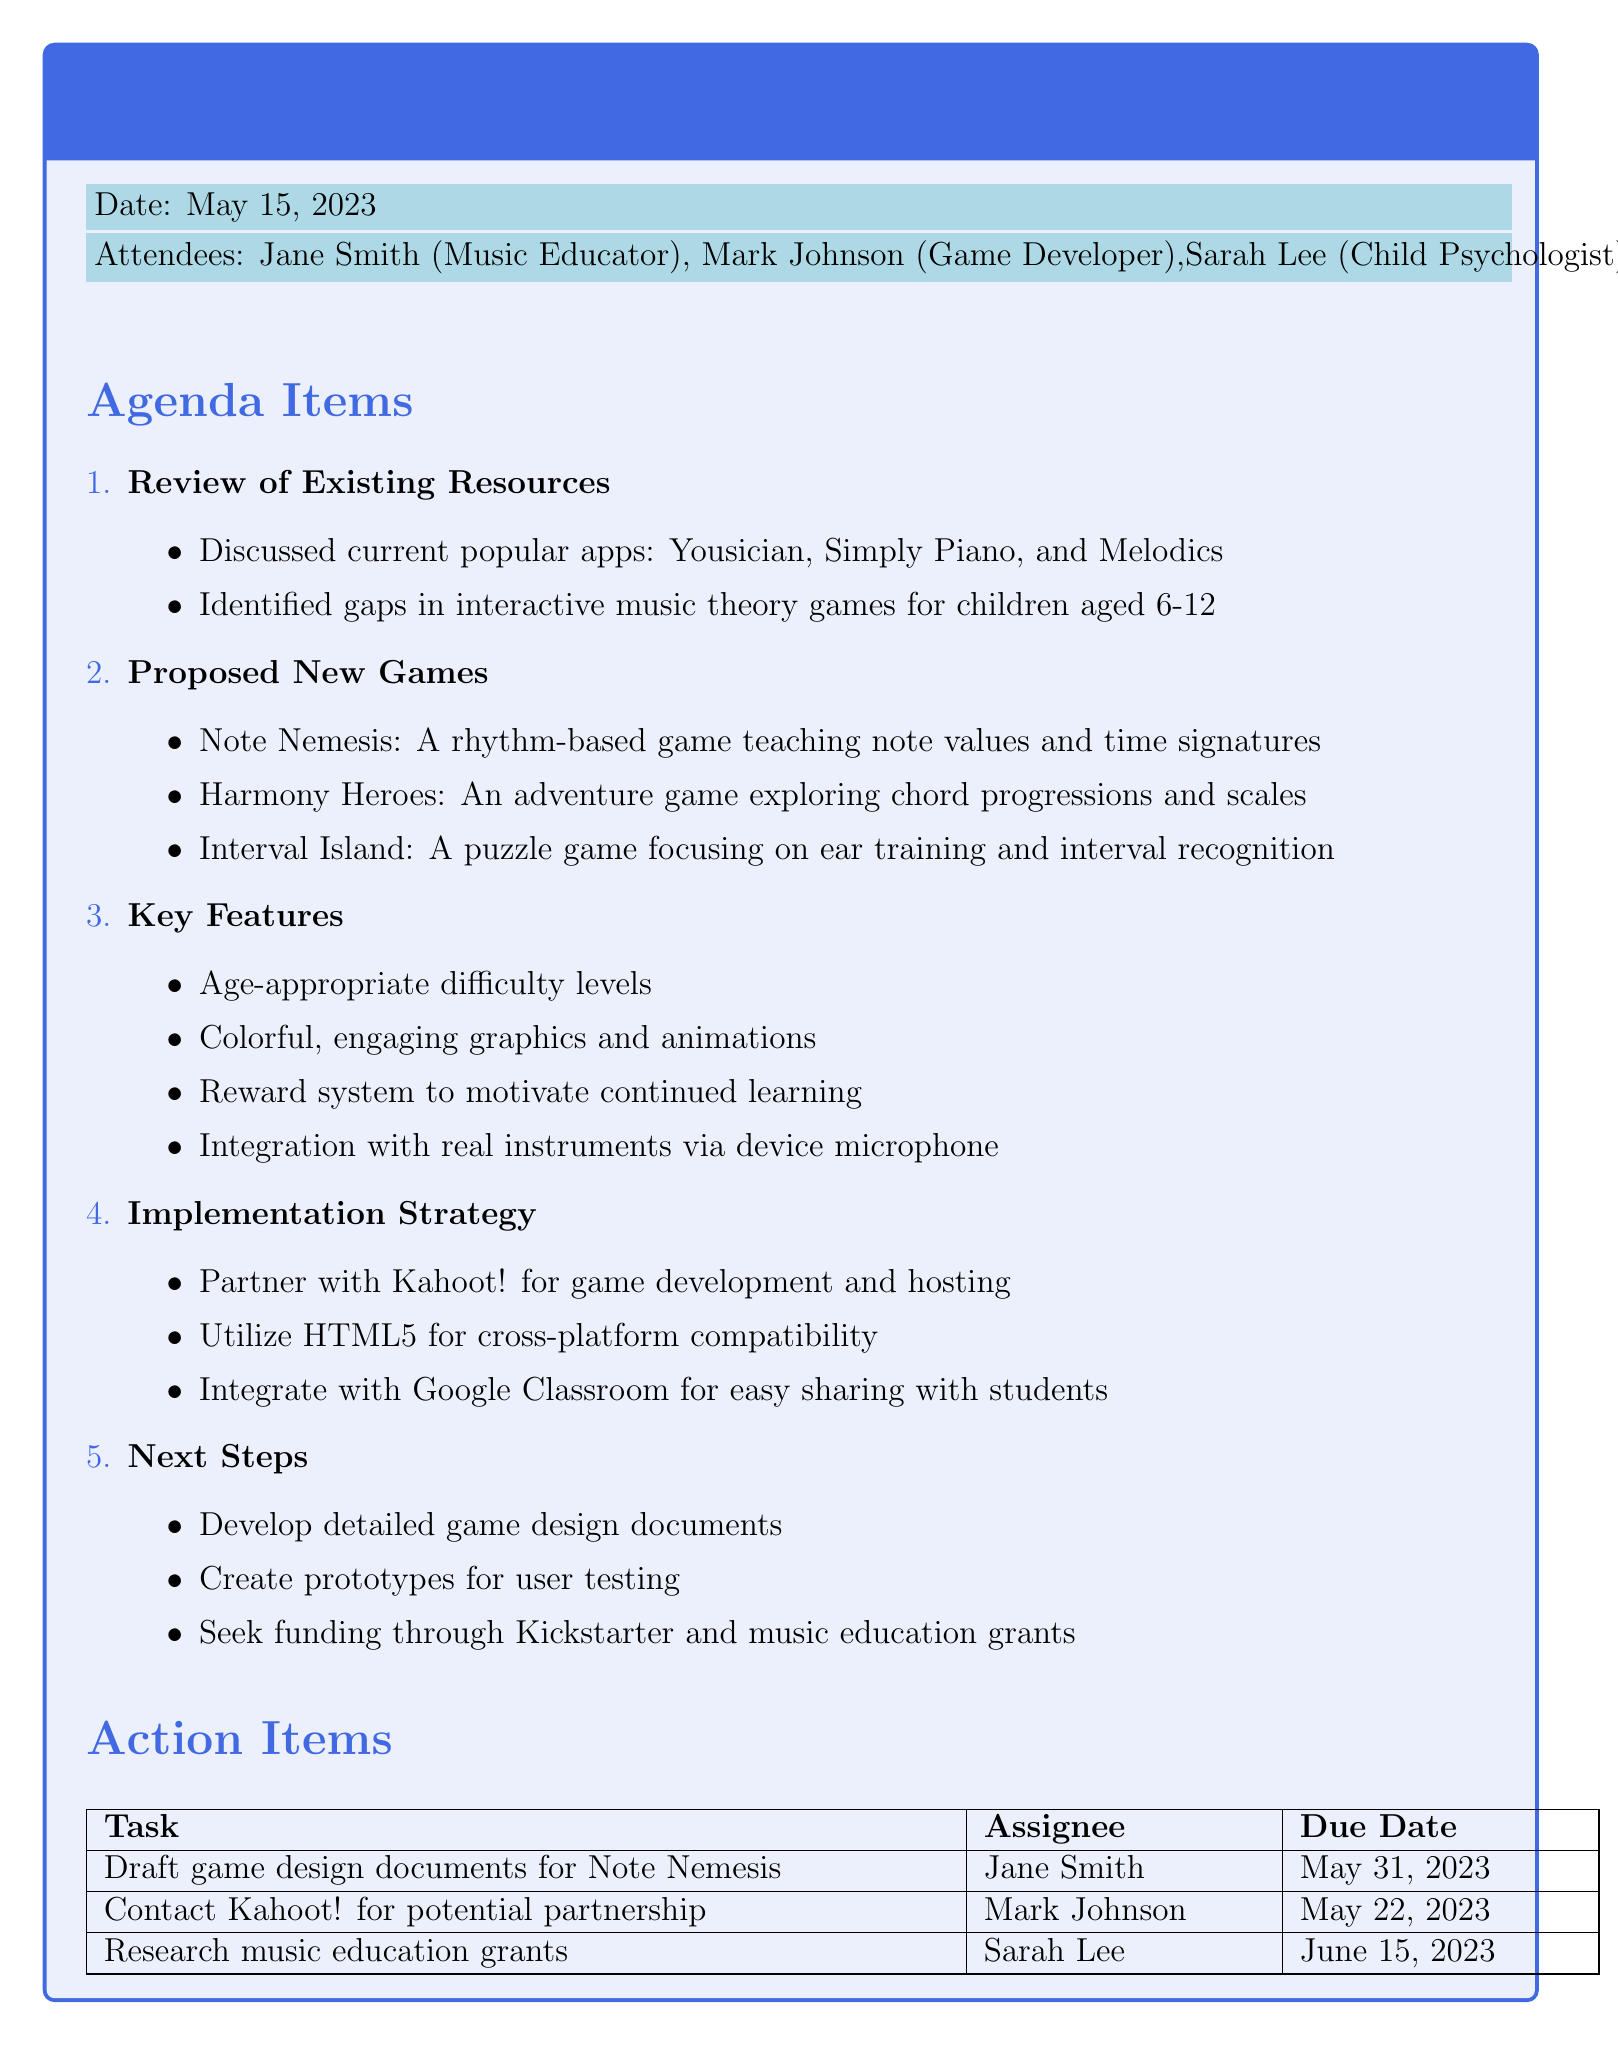What is the date of the meeting? The date of the meeting is mentioned at the beginning of the document as May 15, 2023.
Answer: May 15, 2023 Who is the game developer attending the meeting? The attendees list includes Mark Johnson, who is identified as the Game Developer.
Answer: Mark Johnson What is one game proposed in the meeting? The document lists proposed new games, one of which is Note Nemesis.
Answer: Note Nemesis What is one key feature mentioned for the games? The document specifies several key features, one being age-appropriate difficulty levels.
Answer: Age-appropriate difficulty levels What is the due date for contacting Kahoot! for a potential partnership? The action item specifies that Mark Johnson is to contact Kahoot! by May 22, 2023.
Answer: May 22, 2023 How many attendees were present at the meeting? The list of attendees includes four individuals mentioned in the document.
Answer: Four What type of games is "Interval Island"? The document identifies Interval Island as a puzzle game focusing on ear training and interval recognition.
Answer: Puzzle game What is the partnership mentioned for game development? The document states that there is a planned partnership with Kahoot! for game development and hosting.
Answer: Kahoot! What is one proposed next step after the meeting? The document lists several next steps, one of which is to develop detailed game design documents.
Answer: Develop detailed game design documents 